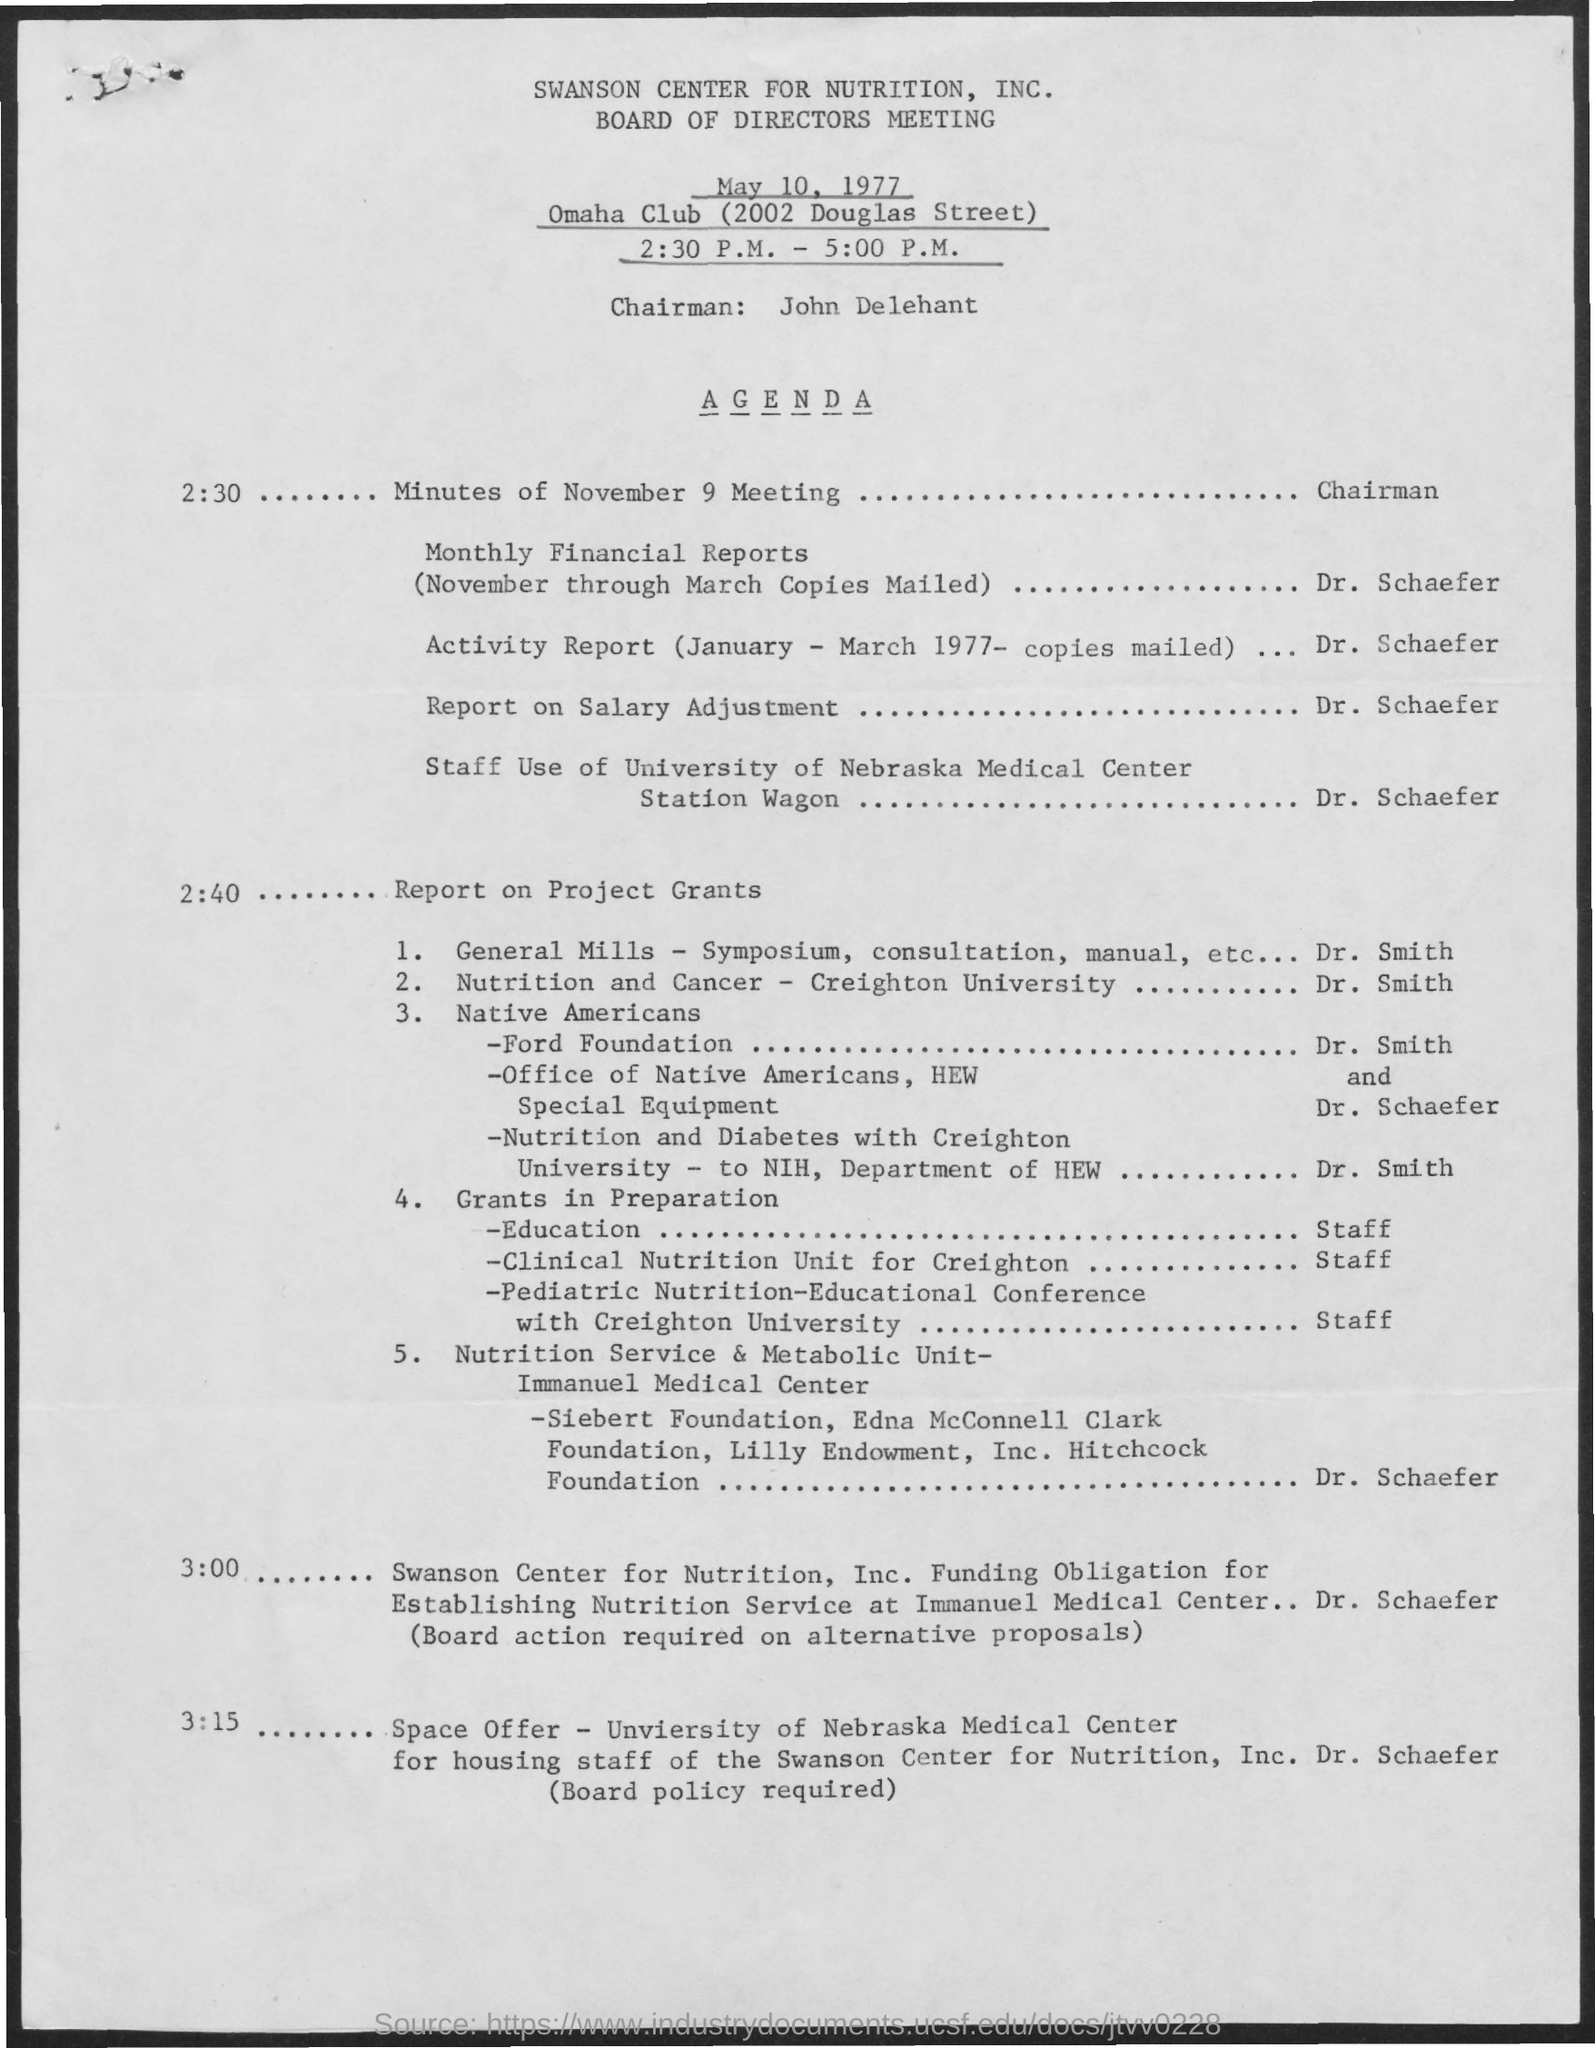What is the name of the meeting ?
Your answer should be very brief. Board of directors meeting. What is the date mentioned ?
Make the answer very short. May 10, 1977. What is the time mentioned ?
Your answer should be compact. 2:30 P.M. - 5:00 P.M. What is the name of the chairman mentioned ?
Ensure brevity in your answer.  John delehant. What is the name of the club mentioned ?
Give a very brief answer. Omaha club. 